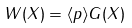<formula> <loc_0><loc_0><loc_500><loc_500>W ( X ) = \langle p \rangle G ( X )</formula> 